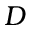<formula> <loc_0><loc_0><loc_500><loc_500>D</formula> 